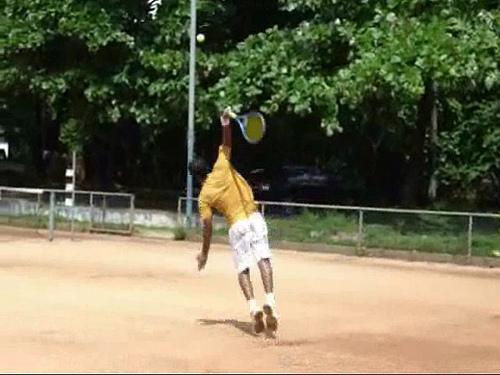Did he hit the ball?
Be succinct. No. Is the man athletic?
Concise answer only. Yes. What sport is the man playing?
Answer briefly. Tennis. 